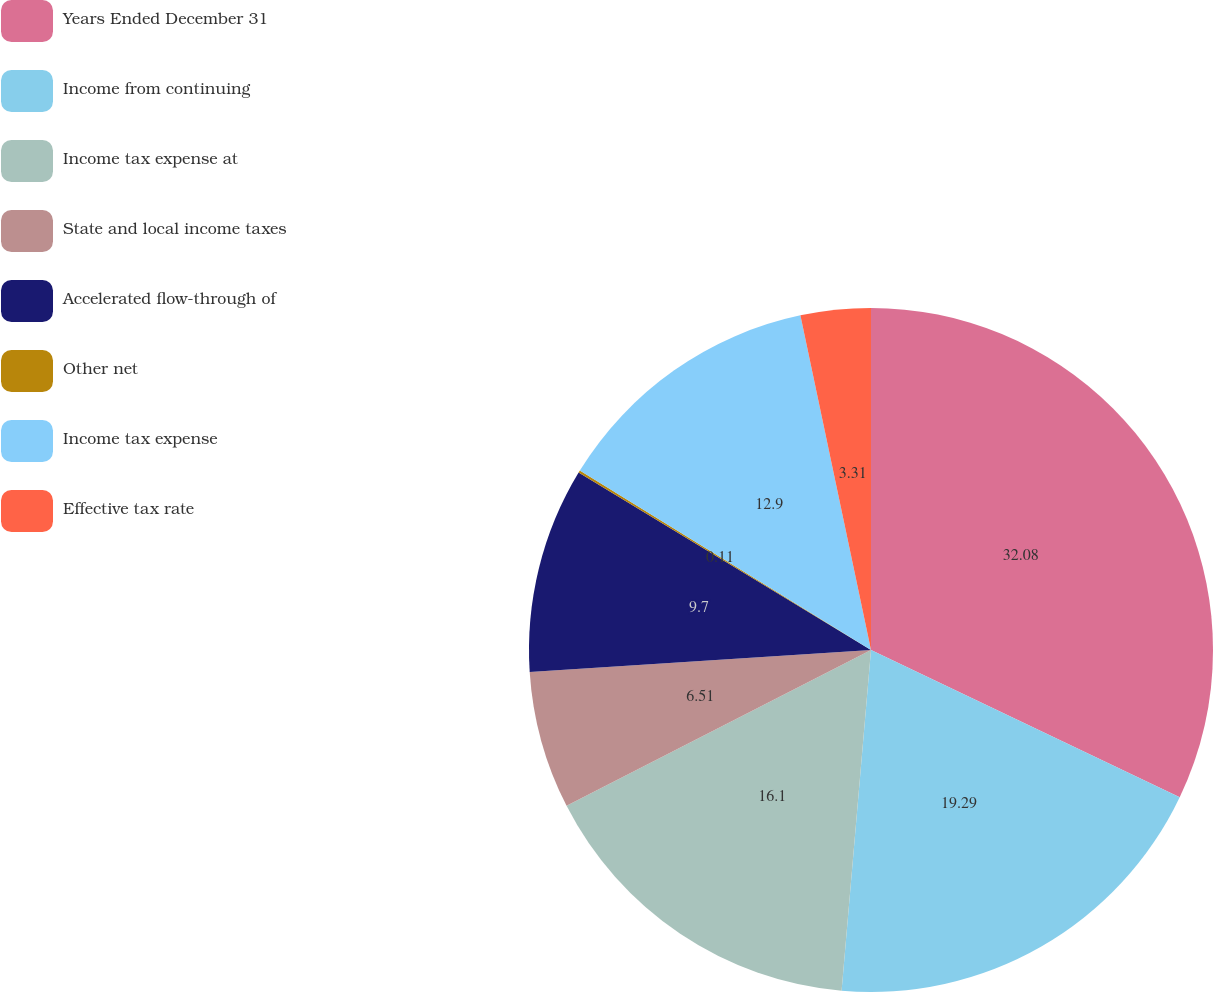<chart> <loc_0><loc_0><loc_500><loc_500><pie_chart><fcel>Years Ended December 31<fcel>Income from continuing<fcel>Income tax expense at<fcel>State and local income taxes<fcel>Accelerated flow-through of<fcel>Other net<fcel>Income tax expense<fcel>Effective tax rate<nl><fcel>32.08%<fcel>19.29%<fcel>16.1%<fcel>6.51%<fcel>9.7%<fcel>0.11%<fcel>12.9%<fcel>3.31%<nl></chart> 